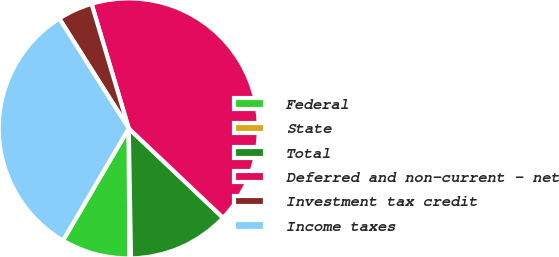Convert chart. <chart><loc_0><loc_0><loc_500><loc_500><pie_chart><fcel>Federal<fcel>State<fcel>Total<fcel>Deferred and non-current - net<fcel>Investment tax credit<fcel>Income taxes<nl><fcel>8.51%<fcel>0.21%<fcel>12.65%<fcel>41.69%<fcel>4.36%<fcel>32.58%<nl></chart> 